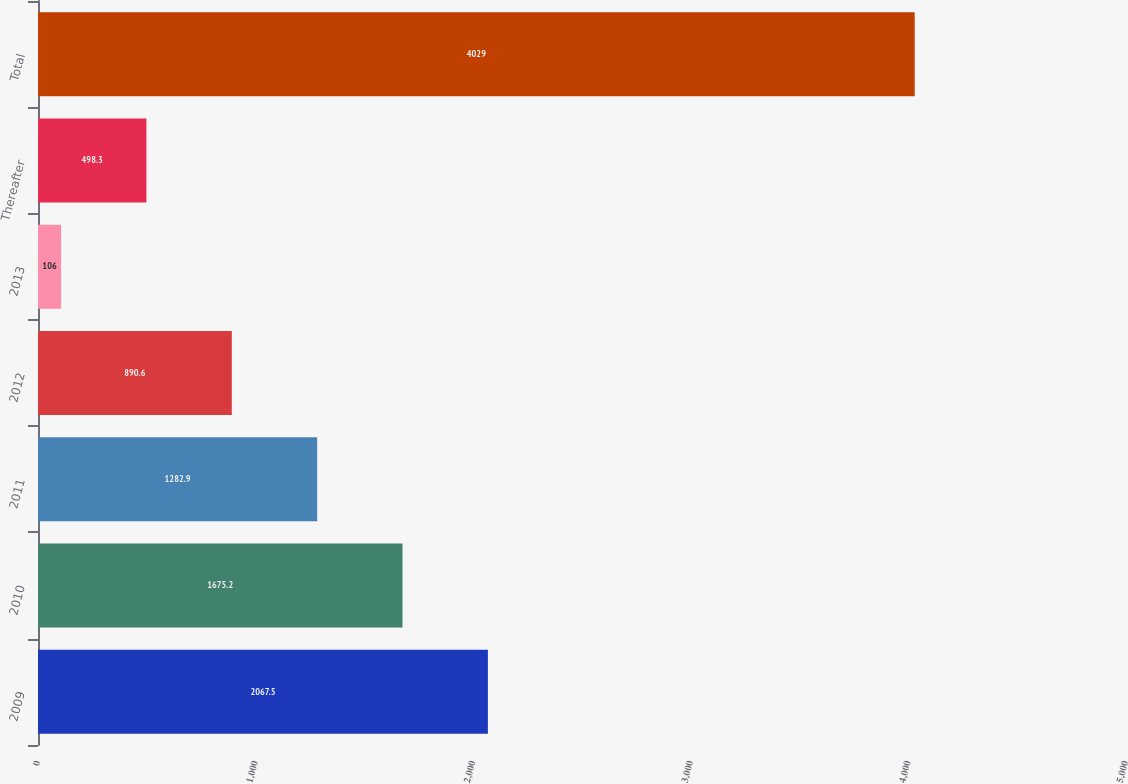<chart> <loc_0><loc_0><loc_500><loc_500><bar_chart><fcel>2009<fcel>2010<fcel>2011<fcel>2012<fcel>2013<fcel>Thereafter<fcel>Total<nl><fcel>2067.5<fcel>1675.2<fcel>1282.9<fcel>890.6<fcel>106<fcel>498.3<fcel>4029<nl></chart> 